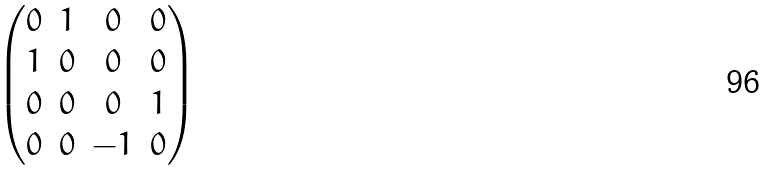<formula> <loc_0><loc_0><loc_500><loc_500>\begin{pmatrix} 0 & 1 & 0 & 0 \\ 1 & 0 & 0 & 0 \\ 0 & 0 & 0 & 1 \\ 0 & 0 & - 1 & 0 \end{pmatrix}</formula> 